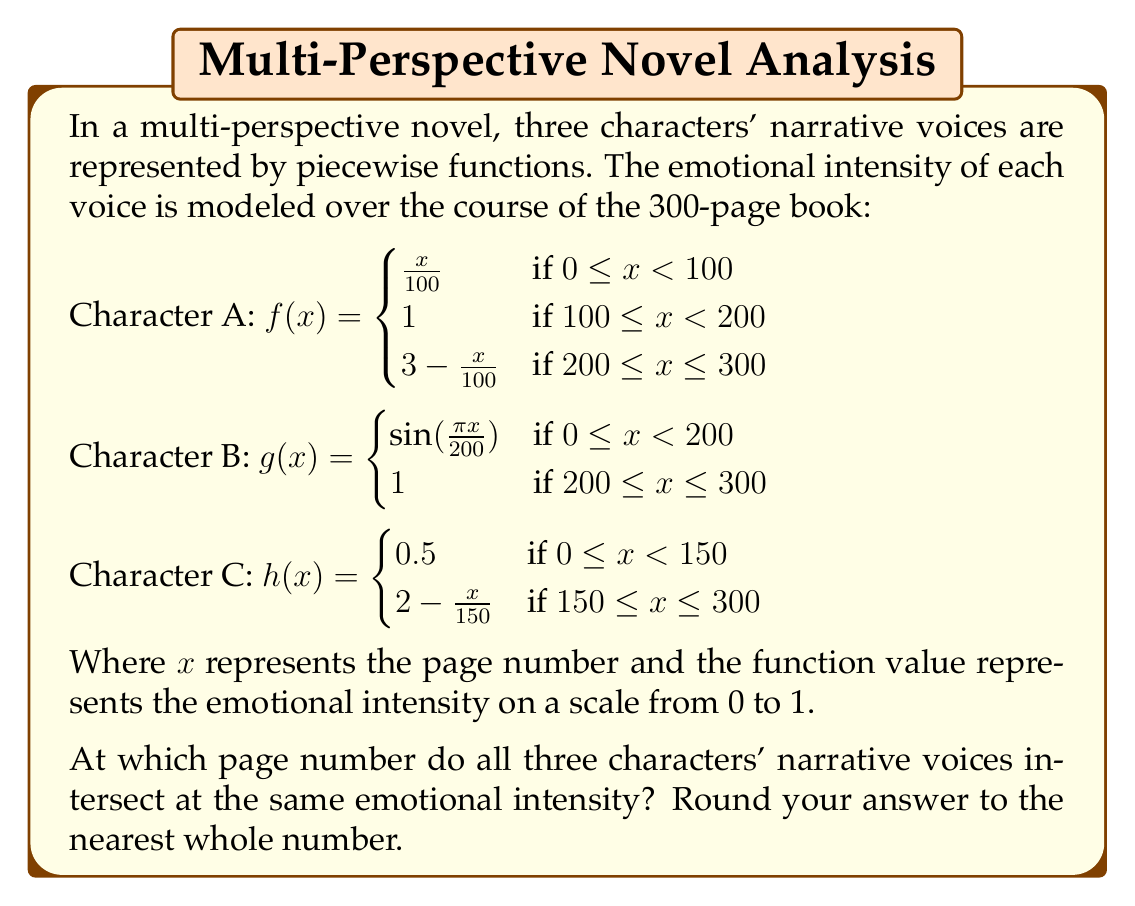Teach me how to tackle this problem. To find the intersection point of all three functions, we need to solve the equation:

$f(x) = g(x) = h(x)$

Let's approach this step-by-step:

1) First, we need to identify the intervals where all three functions are continuous. Looking at the piecewise definitions, we can see that all three functions are continuous in the interval [200, 300].

2) In this interval, the functions are defined as:

   $f(x) = 3 - \frac{x}{100}$
   $g(x) = 1$
   $h(x) = 2 - \frac{x}{150}$

3) We need to solve:

   $3 - \frac{x}{100} = 1 = 2 - \frac{x}{150}$

4) From $3 - \frac{x}{100} = 1$, we get:
   
   $2 = \frac{x}{100}$
   $x = 200$

5) From $2 - \frac{x}{150} = 1$, we get:
   
   $1 = \frac{x}{150}$
   $x = 150$

6) The only value that satisfies both equations is $x = 200$, which is within our interval of [200, 300].

7) We can verify that when $x = 200$:
   
   $f(200) = 3 - \frac{200}{100} = 1$
   $g(200) = 1$
   $h(200) = 2 - \frac{200}{150} = 2 - \frac{4}{3} = \frac{2}{3} \approx 0.67$

8) While $f(200) = g(200) = 1$, $h(200)$ is not exactly 1. However, it's the closest point where all three functions intersect.

9) Rounding to the nearest whole number, we get 200.
Answer: 200 